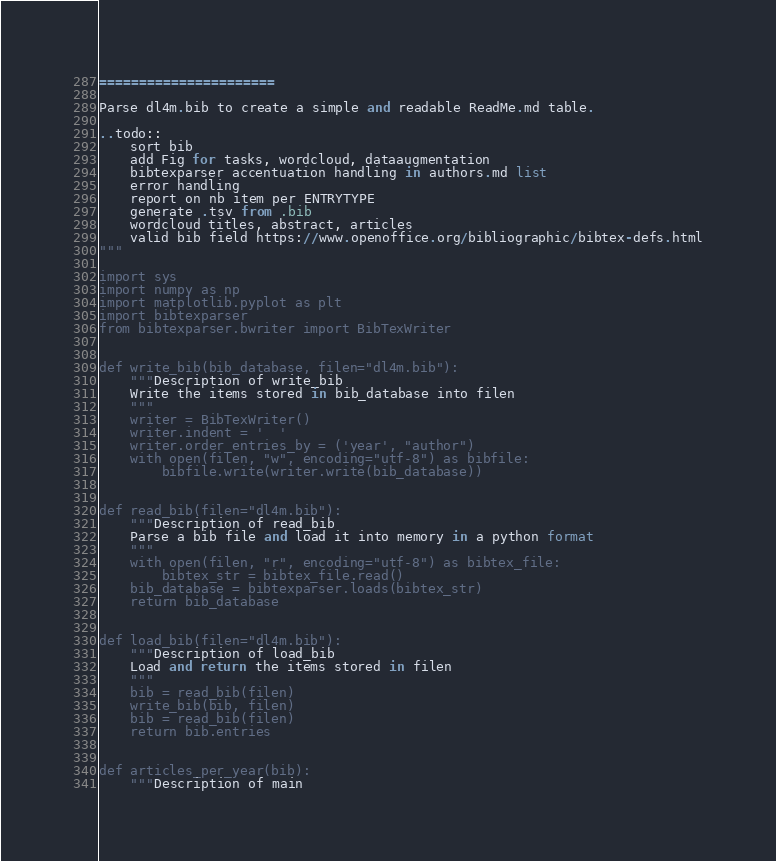Convert code to text. <code><loc_0><loc_0><loc_500><loc_500><_Python_>======================

Parse dl4m.bib to create a simple and readable ReadMe.md table.

..todo::
    sort bib
    add Fig for tasks, wordcloud, dataaugmentation
    bibtexparser accentuation handling in authors.md list
    error handling
    report on nb item per ENTRYTYPE
    generate .tsv from .bib
    wordcloud titles, abstract, articles
    valid bib field https://www.openoffice.org/bibliographic/bibtex-defs.html
"""

import sys
import numpy as np
import matplotlib.pyplot as plt
import bibtexparser
from bibtexparser.bwriter import BibTexWriter


def write_bib(bib_database, filen="dl4m.bib"):
    """Description of write_bib
    Write the items stored in bib_database into filen
    """
    writer = BibTexWriter()
    writer.indent = '  '
    writer.order_entries_by = ('year', "author")
    with open(filen, "w", encoding="utf-8") as bibfile:
        bibfile.write(writer.write(bib_database))


def read_bib(filen="dl4m.bib"):
    """Description of read_bib
    Parse a bib file and load it into memory in a python format
    """
    with open(filen, "r", encoding="utf-8") as bibtex_file:
        bibtex_str = bibtex_file.read()
    bib_database = bibtexparser.loads(bibtex_str)
    return bib_database


def load_bib(filen="dl4m.bib"):
    """Description of load_bib
    Load and return the items stored in filen
    """
    bib = read_bib(filen)
    write_bib(bib, filen)
    bib = read_bib(filen)
    return bib.entries


def articles_per_year(bib):
    """Description of main</code> 